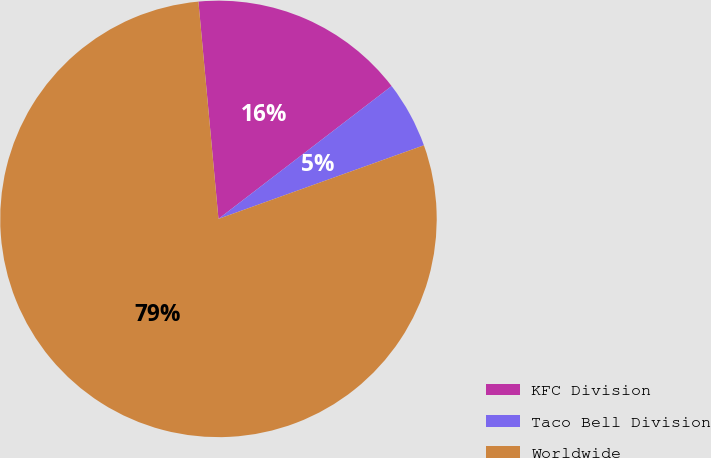Convert chart. <chart><loc_0><loc_0><loc_500><loc_500><pie_chart><fcel>KFC Division<fcel>Taco Bell Division<fcel>Worldwide<nl><fcel>16.05%<fcel>4.94%<fcel>79.01%<nl></chart> 